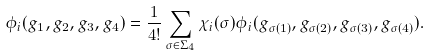<formula> <loc_0><loc_0><loc_500><loc_500>\phi _ { i } ( g _ { 1 } , g _ { 2 } , g _ { 3 } , g _ { 4 } ) = { \frac { 1 } { 4 ! } } \sum _ { \sigma \in \Sigma _ { 4 } } \chi _ { i } ( \sigma ) \phi _ { i } ( g _ { \sigma ( 1 ) } , g _ { \sigma ( 2 ) } , g _ { \sigma ( 3 ) } , g _ { \sigma ( 4 ) } ) .</formula> 